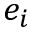<formula> <loc_0><loc_0><loc_500><loc_500>e _ { i }</formula> 